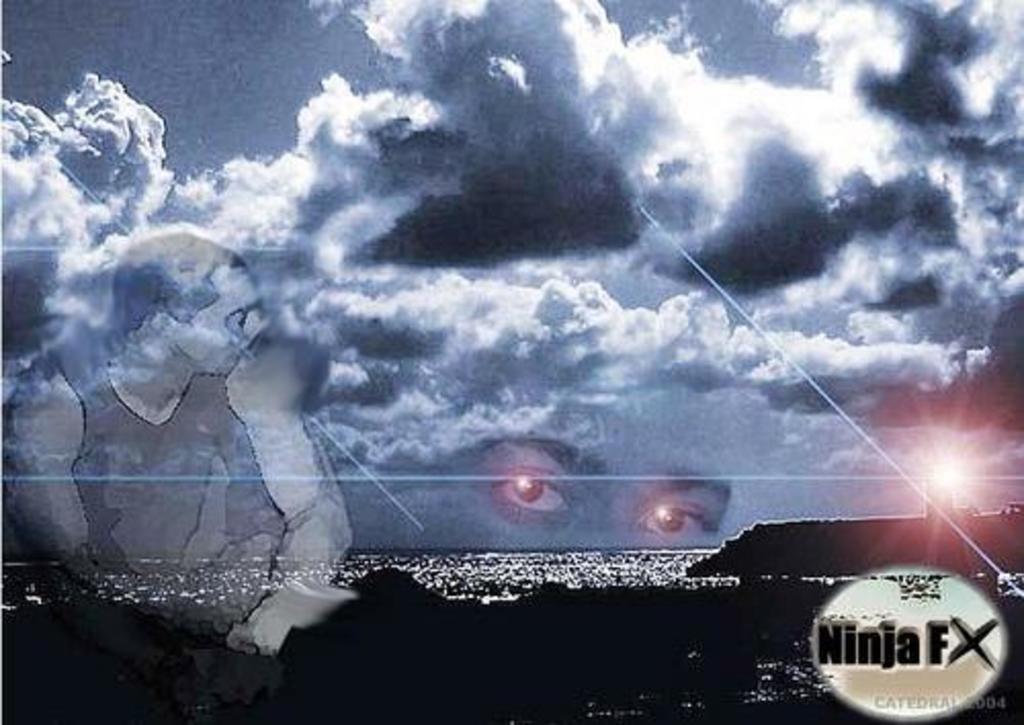Could you give a brief overview of what you see in this image? In this image we can see the sea, the sun, a person, a person's eyes, text on the image, also we can see clouds, and the sky. 